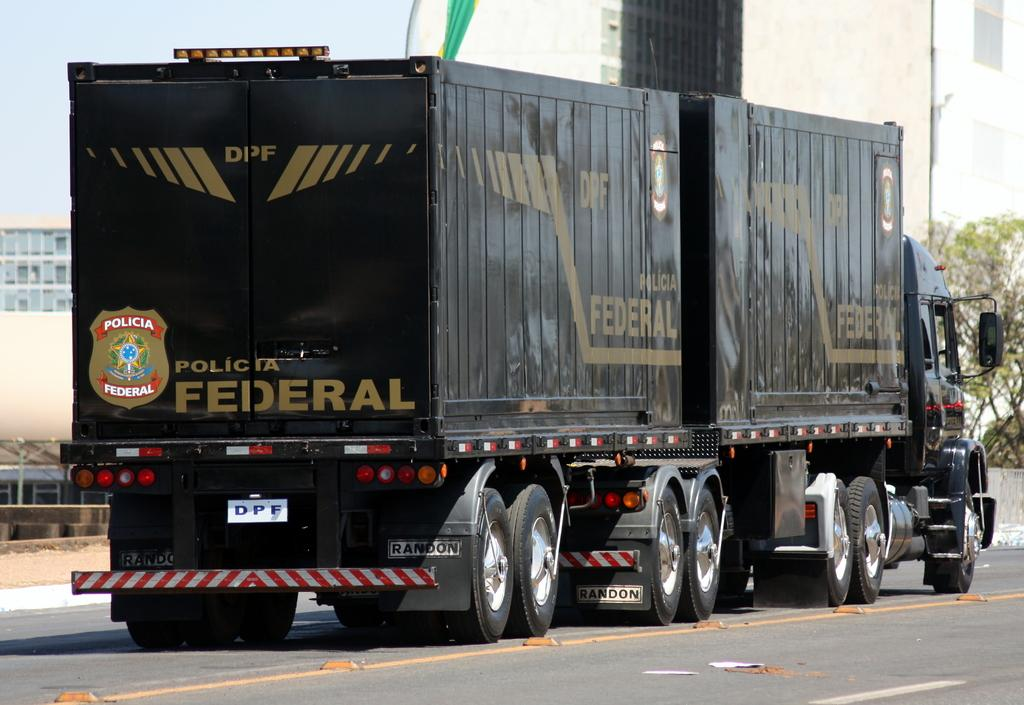What type of vehicle is in the image? There is a black color truck in the image. What is the truck doing in the image? The truck is moving on the road. What can be seen in the background of the image? There are buildings and trees in the background of the image. What type of sign is the truck holding in the image? There is no sign present in the image; the truck is simply moving on the road. 